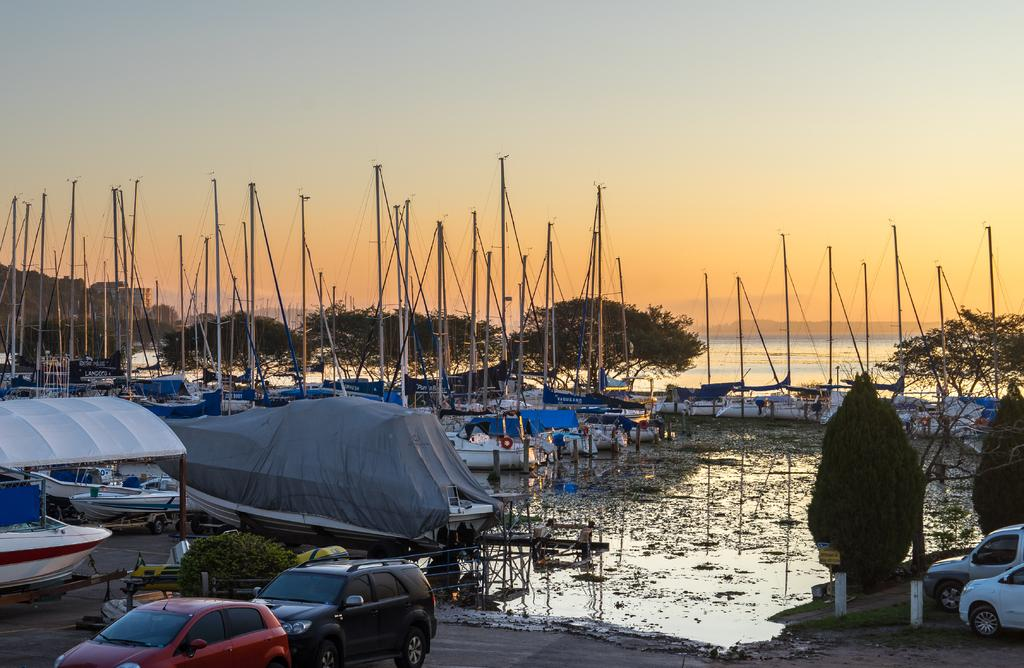What can be seen floating in the water in the image? There are many boats in the water in the image. What structures are present in the image? There are poles in the image. What type of transportation is visible in the image? There are vehicles in the image. What type of vegetation is present in the image? Trees are present in the image. What type of ground cover is visible in the image? Grass is visible in the image. What part of the natural environment is visible in the image? The sky is visible in the image. What type of yoke is being used to control the beetle in the image? There is no beetle or yoke present in the image. How is the paste being applied to the trees in the image? There is no paste present in the image, and the trees are not being treated with any substance. 